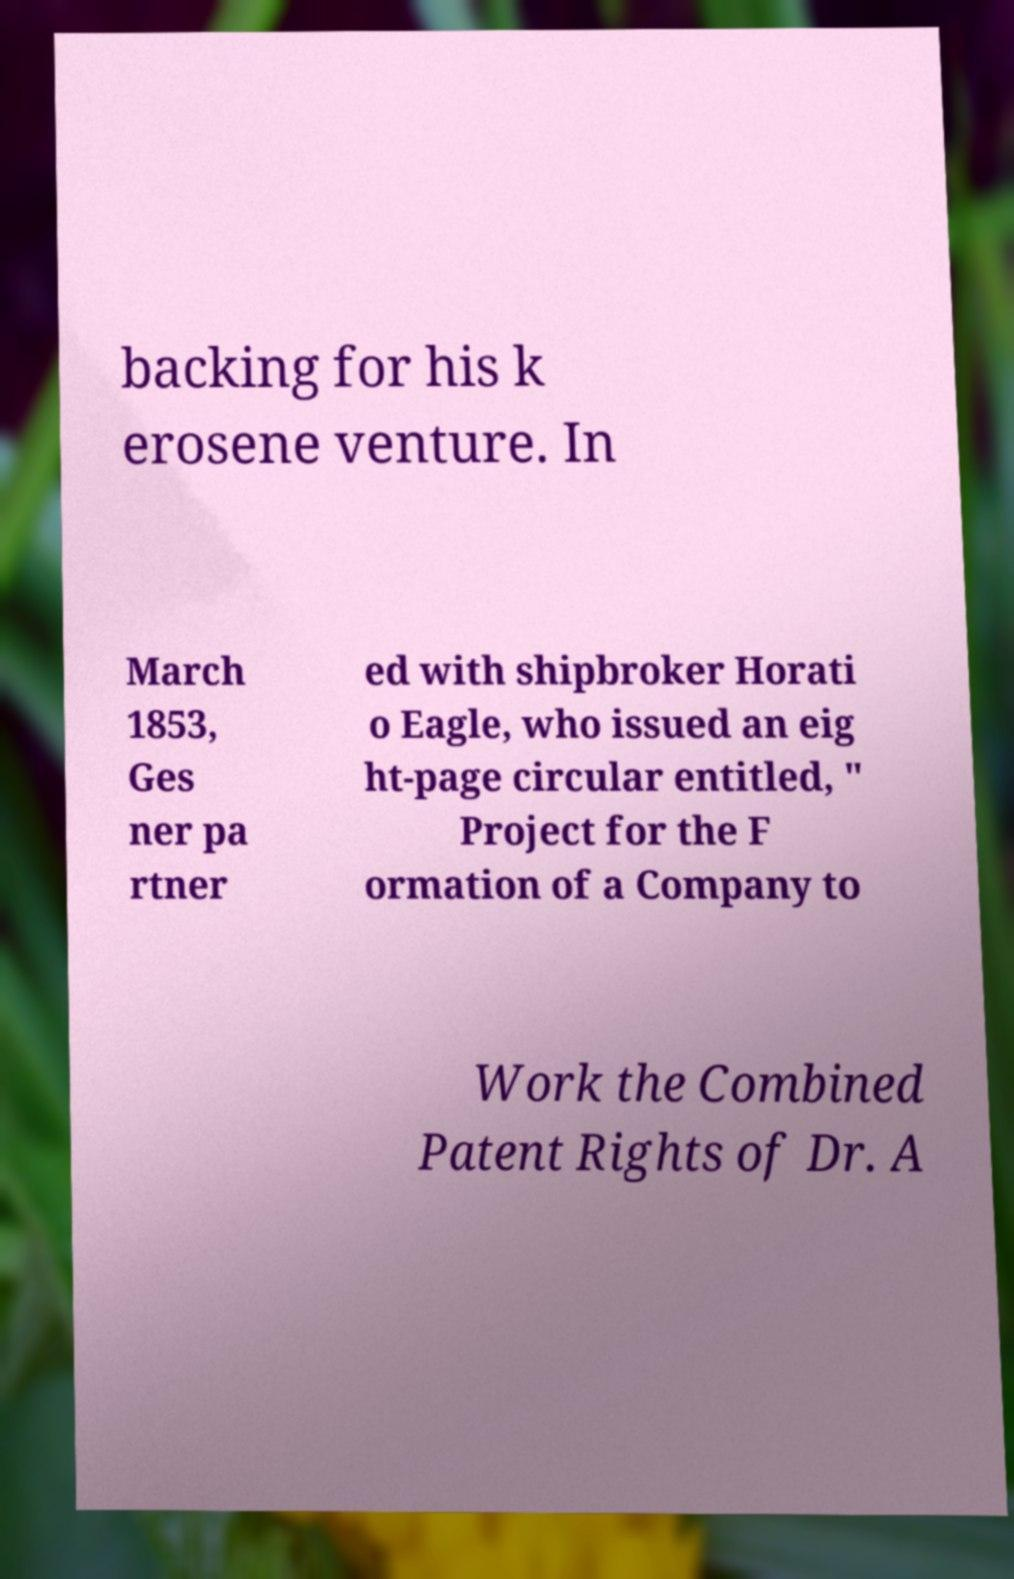Can you read and provide the text displayed in the image?This photo seems to have some interesting text. Can you extract and type it out for me? backing for his k erosene venture. In March 1853, Ges ner pa rtner ed with shipbroker Horati o Eagle, who issued an eig ht-page circular entitled, " Project for the F ormation of a Company to Work the Combined Patent Rights of Dr. A 